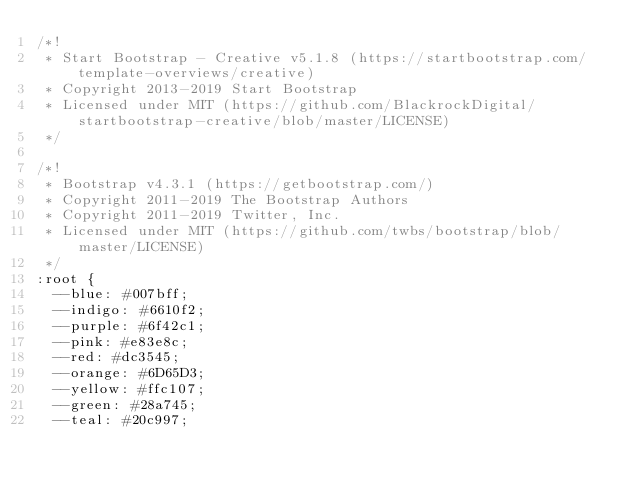Convert code to text. <code><loc_0><loc_0><loc_500><loc_500><_CSS_>/*!
 * Start Bootstrap - Creative v5.1.8 (https://startbootstrap.com/template-overviews/creative)
 * Copyright 2013-2019 Start Bootstrap
 * Licensed under MIT (https://github.com/BlackrockDigital/startbootstrap-creative/blob/master/LICENSE)
 */

/*!
 * Bootstrap v4.3.1 (https://getbootstrap.com/)
 * Copyright 2011-2019 The Bootstrap Authors
 * Copyright 2011-2019 Twitter, Inc.
 * Licensed under MIT (https://github.com/twbs/bootstrap/blob/master/LICENSE)
 */
:root {
  --blue: #007bff;
  --indigo: #6610f2;
  --purple: #6f42c1;
  --pink: #e83e8c;
  --red: #dc3545;
  --orange: #6D65D3;
  --yellow: #ffc107;
  --green: #28a745;
  --teal: #20c997;</code> 